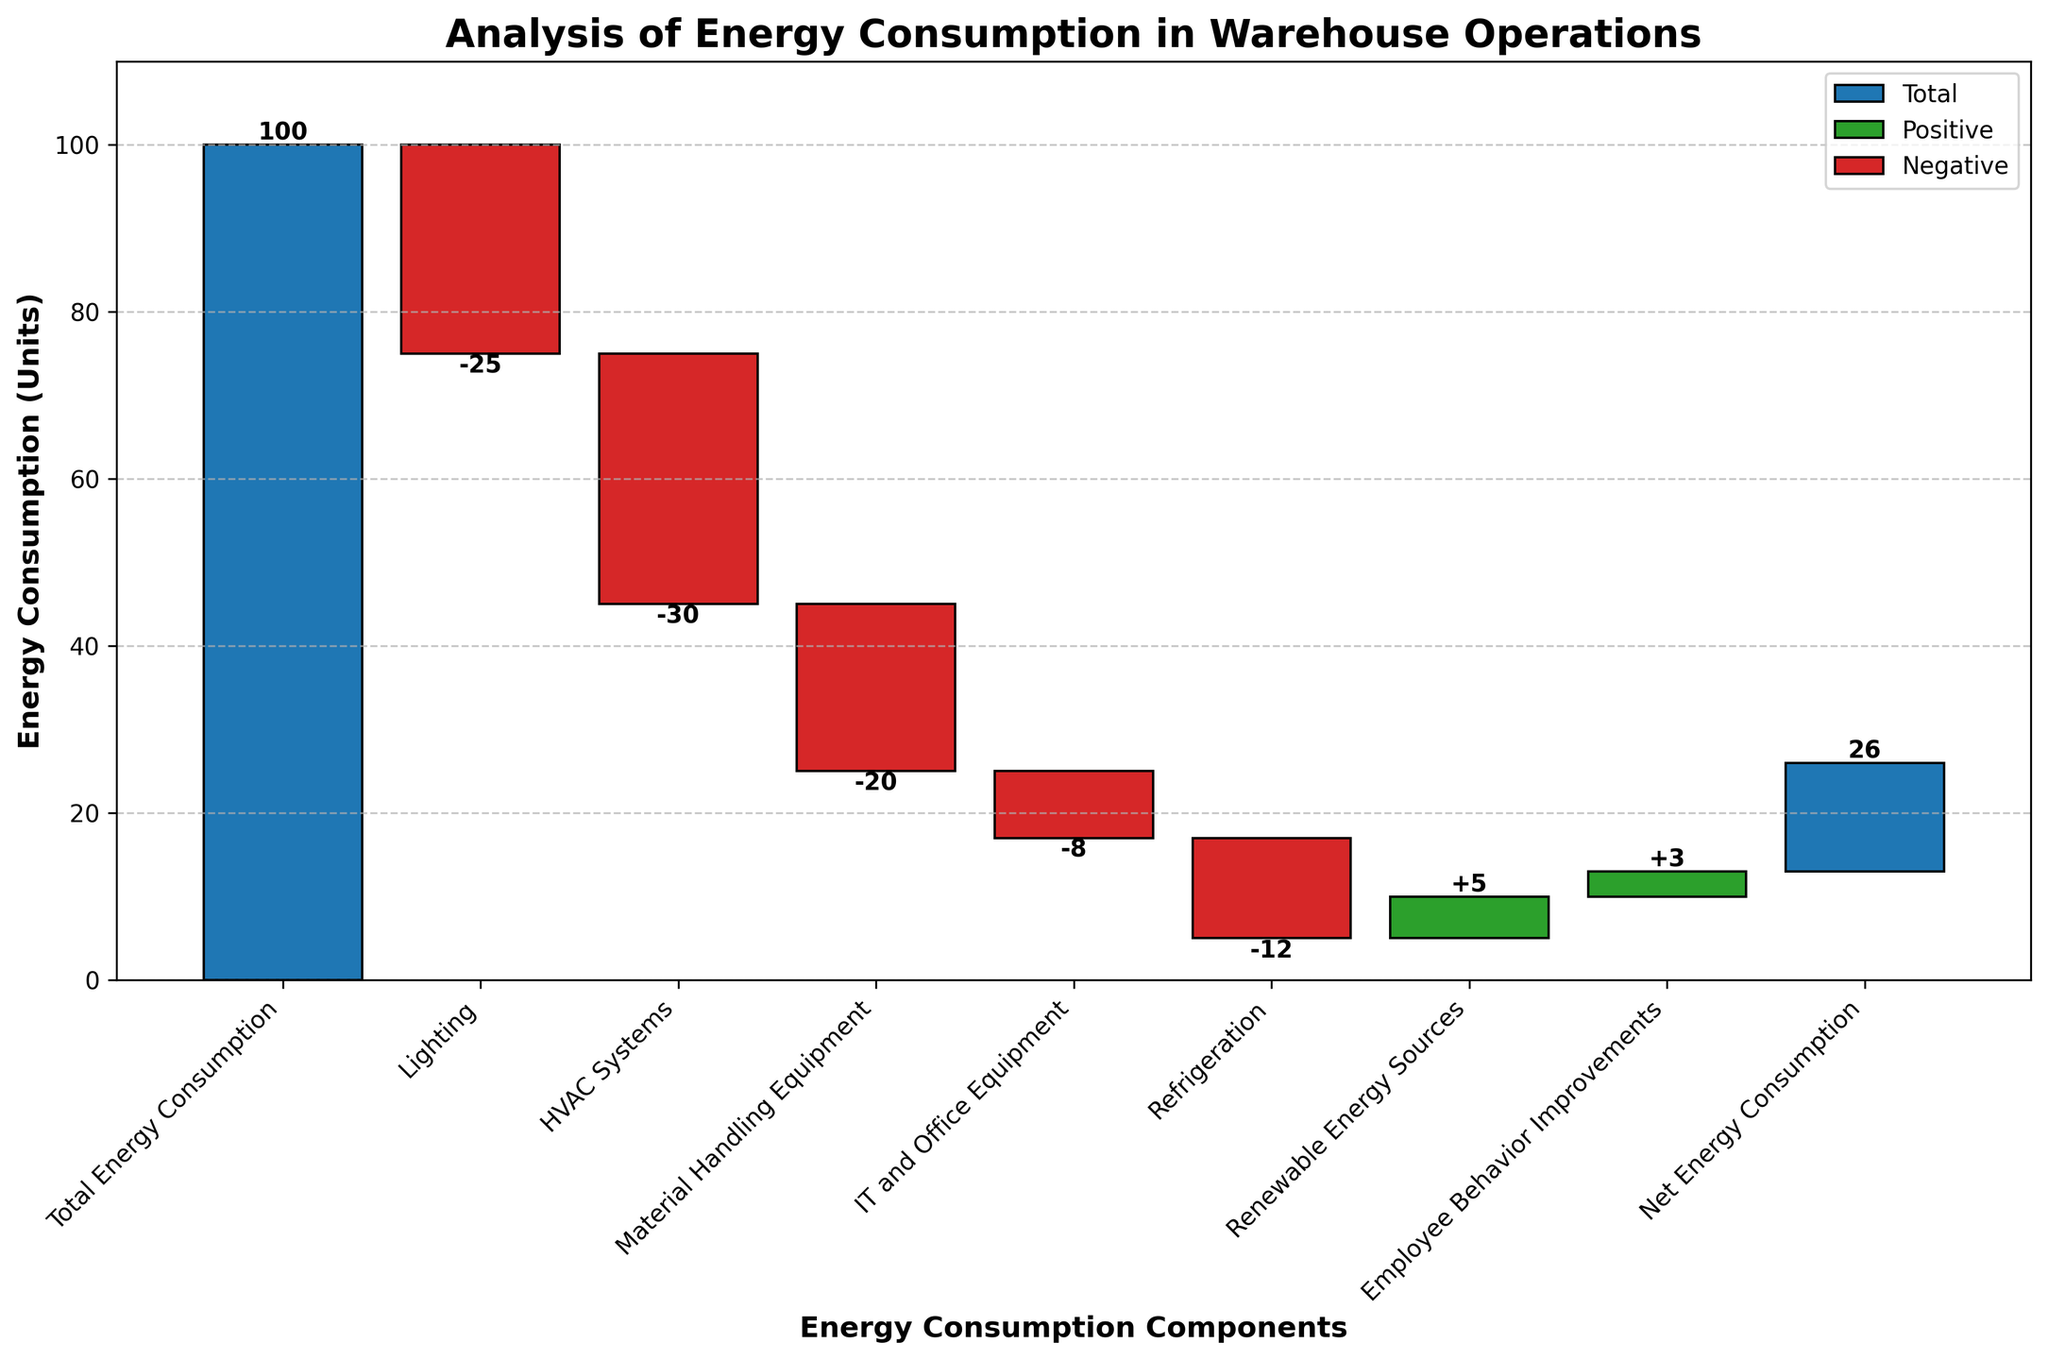How many categories of energy consumption components are shown in the waterfall chart? Count the distinct categories labeled on the x-axis. You can see there are a total of nine categories listed from "Total Energy Consumption" to "Net Energy Consumption".
Answer: 9 What is the initial total energy consumption before any reductions or improvements are applied? Look at the value on the y-axis corresponding to the "Total Energy Consumption" bar. The chart starts with a value of 100.
Answer: 100 By how much does refrigeration reduce energy consumption? Refer to the value labeled for "Refrigeration". The label shows -12, indicating a reduction of 12 units.
Answer: 12 What is the significance of the green bars in the chart? Green bars represent positive values or improvements in energy consumption. There are two green bars, "Renewable Energy Sources" and "Employee Behavior Improvements", showing how much energy is added or saved via positive changes.
Answer: Improvements in energy consumption and renewable sources Which component has the largest negative impact on energy consumption? Compare the negative values of the components directly. "HVAC Systems" has the largest negative value of -30 units.
Answer: HVAC Systems What is the net energy consumption after all reductions and improvements? Look for the final value of the "Net Energy Consumption" bar. The chart indicates this is 13 units.
Answer: 13 How do you calculate the final net energy consumption starting from the total? Start with the total energy consumption of 100 units. Subtract the negative values (-25 for Lighting, -30 for HVAC Systems, -20 for Material Handling Equipment, -8 for IT and Office Equipment, -12 for Refrigeration) and add the positive values (+5 for Renewable Energy Sources, +3 for Employee Behavior Improvements). Summing these adjustments gives the final net energy of 13 units.
Answer: 13 units Which two components have the smallest impact on energy consumption combined? Sum the two smallest absolute values from the categories. IT and Office Equipment (-8) and Employee Behavior Improvements (+3) have the smallest impacts. Summed together, they change the energy by -5 units (negative impact).
Answer: IT and Office Equipment and Employee Behavior Improvements combined give -5 units Describe the overall trend of energy consumption from the initial to the net value Explain the visual flow starting from "Total Energy Consumption" through all the intermediate bars to "Net Energy Consumption". The trend shows a substantial reduction in energy consumption through several negative components, with minor positive contributions towards the end, culminating in a final net consumption that is much lower than the initial total.
Answer: Substantial reduction with minor positive contributions Is the contribution from renewable energy significant compared to other components? Compare the bars for "Renewable Energy Sources" with other bars. The contribution from renewable energy is +5, which is relatively small compared to the larger negative impacts like HVAC Systems (-30).
Answer: No, it is relatively small 